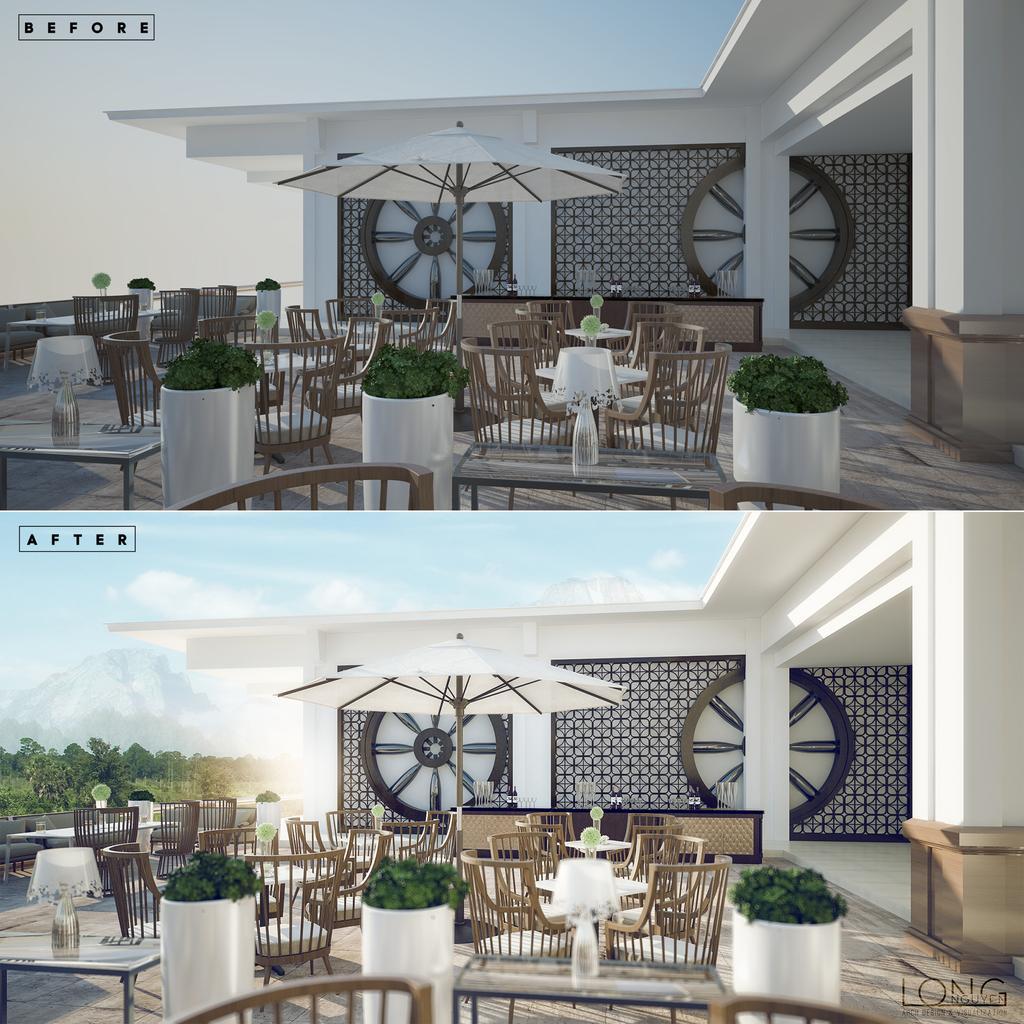Please provide a concise description of this image. This picture describes about collage of two images, in this we can find buildings, plants, chairs, lights, trees and clouds, and also we can find some text. 